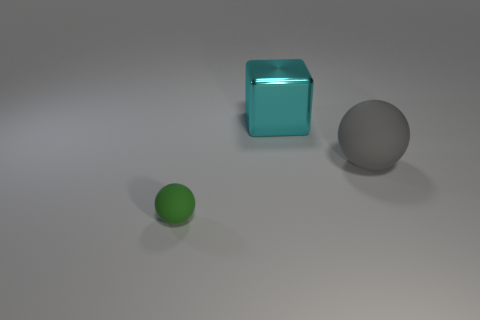What number of gray matte objects have the same size as the gray sphere?
Your answer should be very brief. 0. Is the number of green matte objects that are right of the tiny green thing greater than the number of green objects left of the big gray ball?
Your answer should be compact. No. There is a cyan cube that is the same size as the gray rubber thing; what is its material?
Give a very brief answer. Metal. The cyan shiny object is what shape?
Offer a terse response. Cube. How many green things are either tiny balls or large metal blocks?
Offer a very short reply. 1. There is another gray thing that is the same material as the small thing; what is its size?
Make the answer very short. Large. Is the sphere that is behind the green matte thing made of the same material as the large thing that is behind the large gray ball?
Give a very brief answer. No. How many cylinders are either cyan metallic objects or large gray rubber things?
Ensure brevity in your answer.  0. What number of cyan cubes are in front of the ball that is right of the matte thing that is to the left of the gray object?
Make the answer very short. 0. There is another gray thing that is the same shape as the tiny matte object; what material is it?
Give a very brief answer. Rubber. 